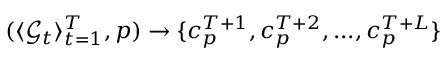<formula> <loc_0><loc_0><loc_500><loc_500>( \langle \mathcal { G } _ { t } \rangle _ { t = 1 } ^ { T } , p ) \to \{ c _ { p } ^ { T + 1 } , c _ { p } ^ { T + 2 } , \dots , c _ { p } ^ { T + L } \}</formula> 